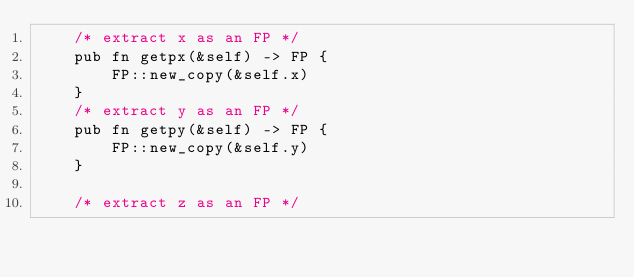<code> <loc_0><loc_0><loc_500><loc_500><_Rust_>    /* extract x as an FP */
    pub fn getpx(&self) -> FP {
        FP::new_copy(&self.x)
    }
    /* extract y as an FP */
    pub fn getpy(&self) -> FP {
        FP::new_copy(&self.y)
    }

    /* extract z as an FP */</code> 